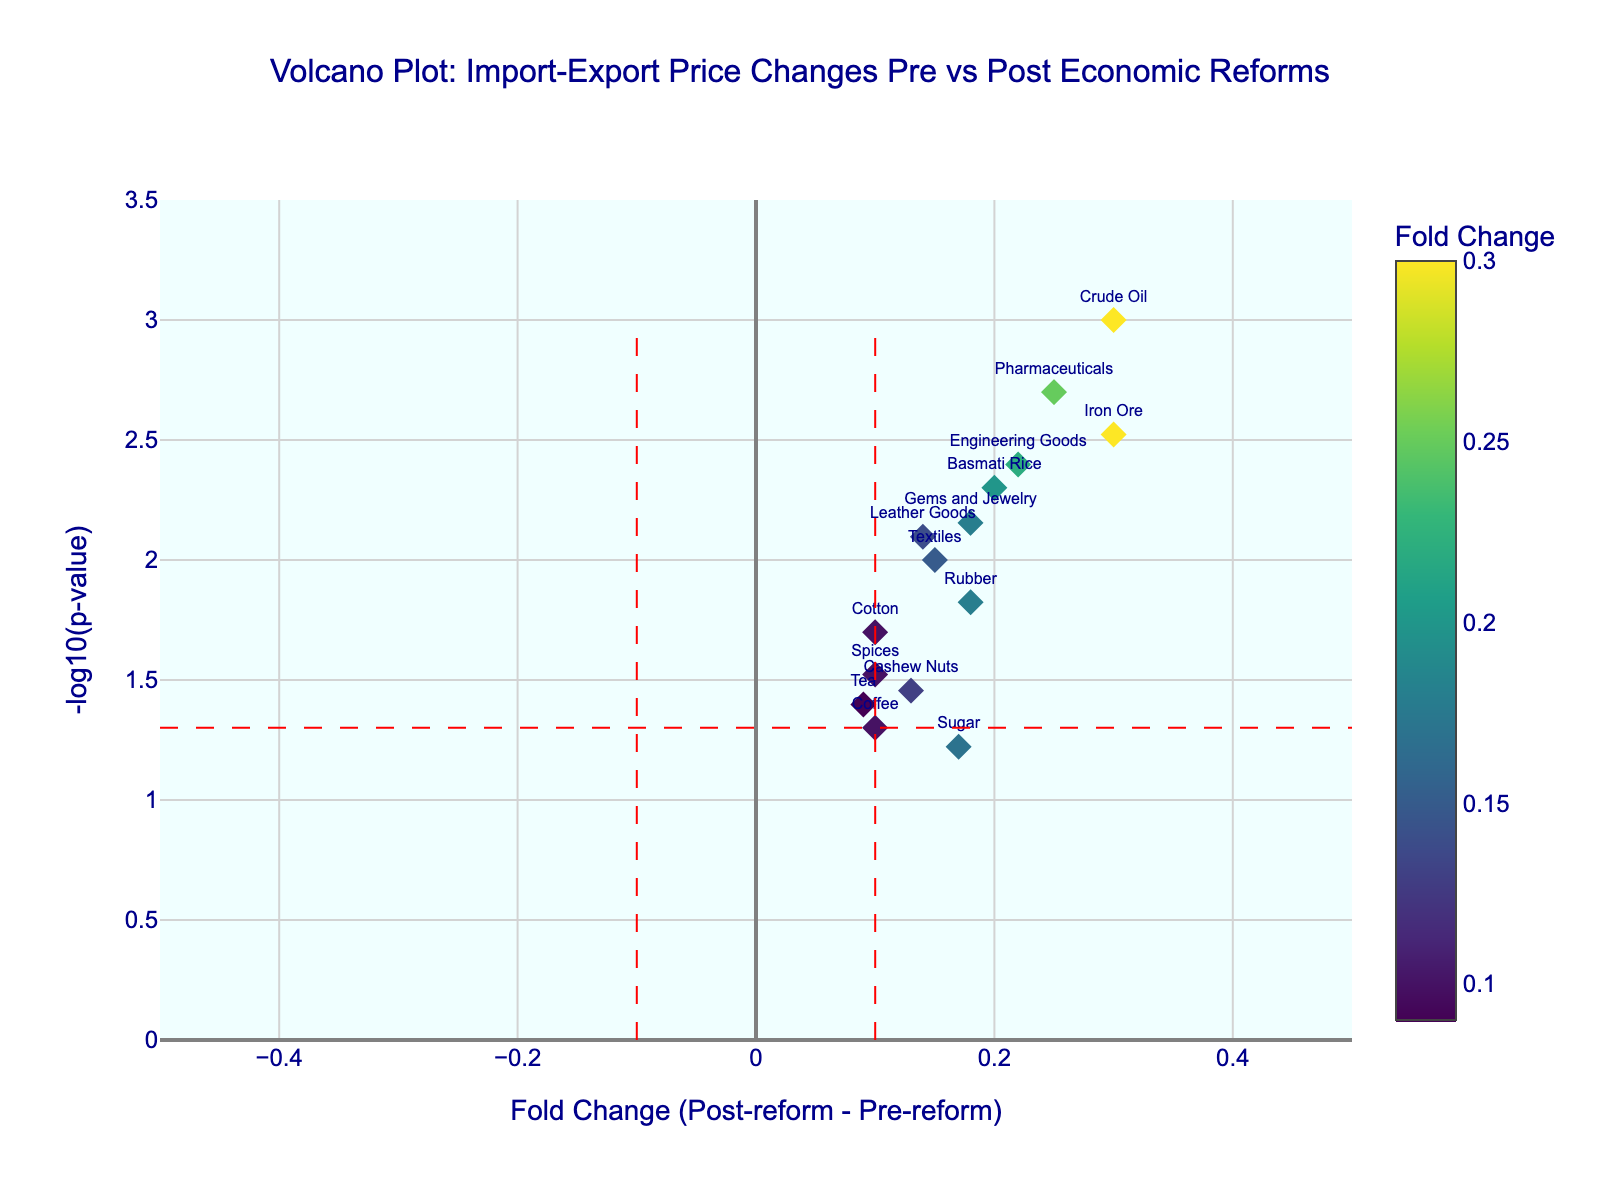What is the title of the volcano plot? The title is displayed at the top center of the plot in a larger font and reads "Volcano Plot: Import-Export Price Changes Pre vs Post Economic Reforms".
Answer: Volcano Plot: Import-Export Price Changes Pre vs Post Economic Reforms Which commodity shows the highest fold change in the post-reform period compared to the pre-reform period? The highest fold change can be identified by the point farthest to the right on the x-axis. Hovering over that point reveals it is "Crude Oil".
Answer: Crude Oil What is the -log10(p-value) for Pharmaceuticals? The -log10(p-value) can be found by locating the point labeled "Pharmaceuticals" and reading its y-axis value. Hovering over it shows a value of approximately 2.70.
Answer: Approximately 2.70 Which commodities have a negative pre-reform to post-reform fold change? The commodities with negative fold change are located on the left side of the plot (x < 0). Hovering over "Iron Ore" and "Sugar" shows they have negative fold changes.
Answer: Iron Ore, Sugar Which commodity has the lowest p-value? The lowest p-value corresponds to the highest -log10(p-value) on the y-axis. The commodity at the top of the plot is "Crude Oil", indicating the lowest p-value.
Answer: Crude Oil Are there any commodities within the fold change threshold of -0.1 to 0.1 but significant in terms of p-value? Look for points between -0.1 and 0.1 on the x-axis, then check if their -log10(p-value) is above the red horizontal line at y ≈ 1.30 (-log10(0.05)). No points meet both criteria.
Answer: No What is the fold change for Leather Goods? Locate the point labeled "Leather Goods" and read its x-axis value. Hovering over the point shows a fold change of approximately 0.14.
Answer: Approximately 0.14 Which commodity shows the smallest -log10(p-value) while having a positive fold change? Find the point with the smallest -log10(p-value) on the y-axis that is also on the right side (positive fold change). "Coffee" with a -log10(p-value) of approximately 1.30 meets this criterion.
Answer: Coffee Which commodity shows a fold change closest to zero? The point closest to the vertical line at x=0 indicates a fold change near zero. "Rubber" with a fold change of approximately 0.18 is the nearest.
Answer: Rubber How many commodities have a fold change greater than 0.2 and a p-value less than 0.05? Count the points to the right of x=0.2 and above the horizontal line y ≈ 1.30 (-log10(0.05)). Commodities that meet the criteria are "Crude Oil", "Engineering Goods", and "Iron Ore", totaling 3.
Answer: 3 